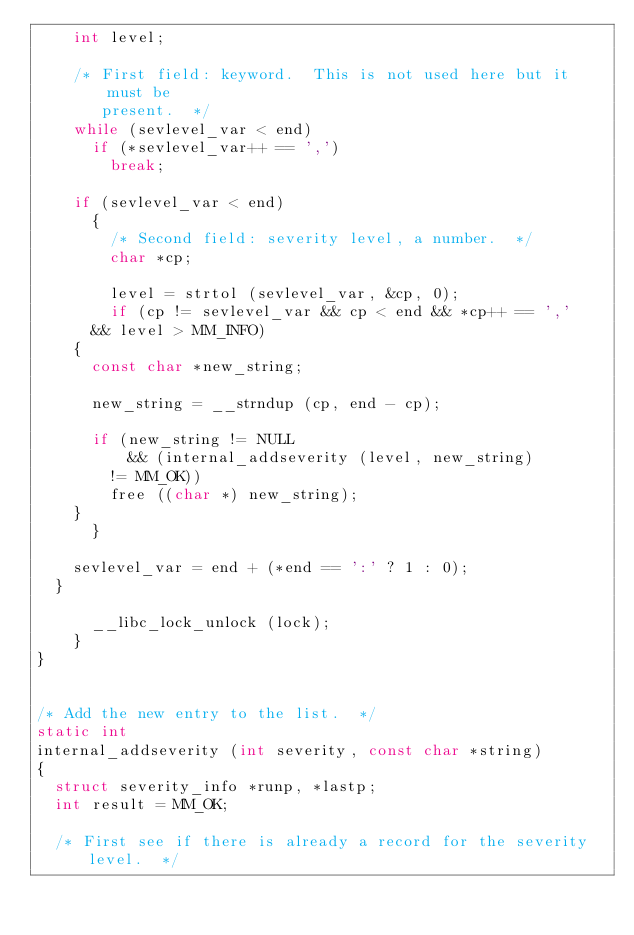<code> <loc_0><loc_0><loc_500><loc_500><_C_>	  int level;

	  /* First field: keyword.  This is not used here but it must be
	     present.  */
	  while (sevlevel_var < end)
	    if (*sevlevel_var++ == ',')
	      break;

	  if (sevlevel_var < end)
	    {
	      /* Second field: severity level, a number.  */
	      char *cp;

	      level = strtol (sevlevel_var, &cp, 0);
	      if (cp != sevlevel_var && cp < end && *cp++ == ','
		  && level > MM_INFO)
		{
		  const char *new_string;

		  new_string = __strndup (cp, end - cp);

		  if (new_string != NULL
		      && (internal_addseverity (level, new_string)
			  != MM_OK))
		    free ((char *) new_string);
		}
	    }

	  sevlevel_var = end + (*end == ':' ? 1 : 0);
	}

      __libc_lock_unlock (lock);
    }
}


/* Add the new entry to the list.  */
static int
internal_addseverity (int severity, const char *string)
{
  struct severity_info *runp, *lastp;
  int result = MM_OK;

  /* First see if there is already a record for the severity level.  */</code> 